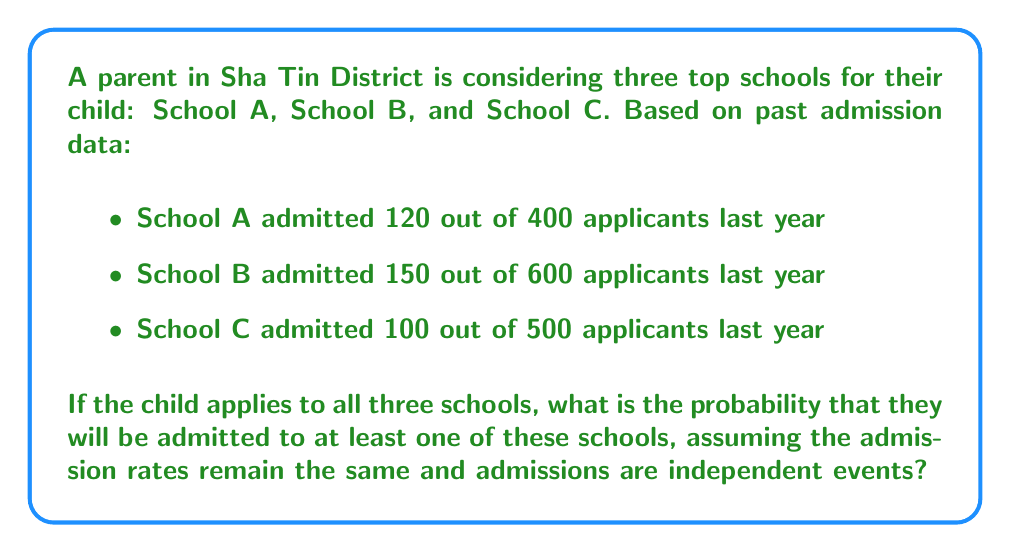What is the answer to this math problem? Let's approach this step-by-step:

1) First, we need to calculate the probability of admission for each school:

   School A: $P(A) = \frac{120}{400} = 0.3$
   School B: $P(B) = \frac{150}{600} = 0.25$
   School C: $P(C) = \frac{100}{500} = 0.2$

2) Now, we need to find the probability of being admitted to at least one school. It's easier to calculate the probability of not being admitted to any school and then subtract that from 1.

3) The probability of not being admitted to a school is the complement of the probability of being admitted:

   Not admitted to A: $1 - P(A) = 1 - 0.3 = 0.7$
   Not admitted to B: $1 - P(B) = 1 - 0.25 = 0.75$
   Not admitted to C: $1 - P(C) = 1 - 0.2 = 0.8$

4) The probability of not being admitted to any of the schools is the product of these probabilities (since we're assuming independent events):

   $P(\text{not admitted to any}) = 0.7 \times 0.75 \times 0.8 = 0.42$

5) Therefore, the probability of being admitted to at least one school is:

   $P(\text{admitted to at least one}) = 1 - P(\text{not admitted to any}) = 1 - 0.42 = 0.58$
Answer: The probability that the child will be admitted to at least one of these schools is 0.58 or 58%. 